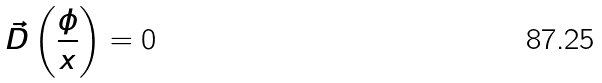<formula> <loc_0><loc_0><loc_500><loc_500>\vec { D } \left ( \frac { \phi } { x } \right ) = 0</formula> 